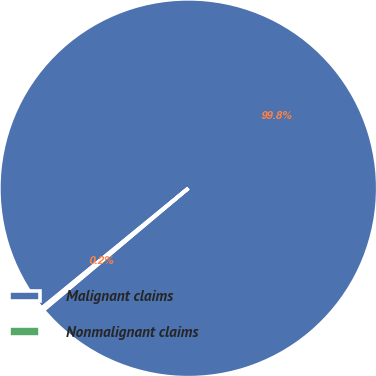Convert chart to OTSL. <chart><loc_0><loc_0><loc_500><loc_500><pie_chart><fcel>Malignant claims<fcel>Nonmalignant claims<nl><fcel>99.78%<fcel>0.22%<nl></chart> 